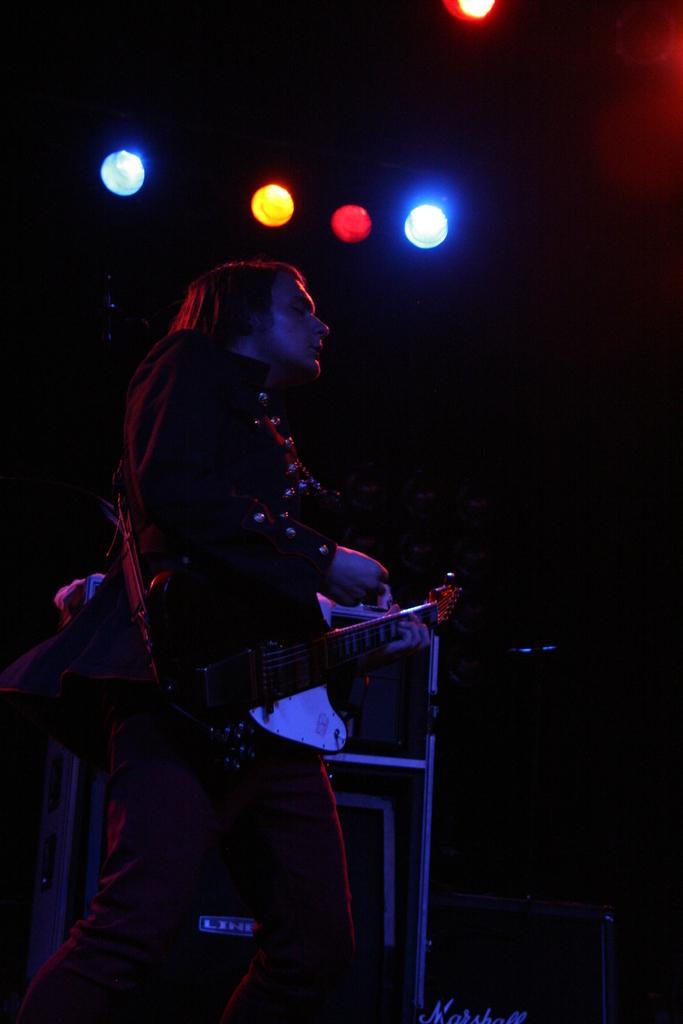Who or what is the main subject of the image? There is a person in the image. What is the person doing or holding in the image? The person is holding a musical instrument in the image. What else can be seen in the image besides the person and the musical instrument? There are lights and some objects in the image. How would you describe the overall appearance of the image? The background of the image is dark. How many bikes are visible in the image? There are no bikes present in the image. What type of fang can be seen on the person in the image? There is no fang present on the person in the image. 